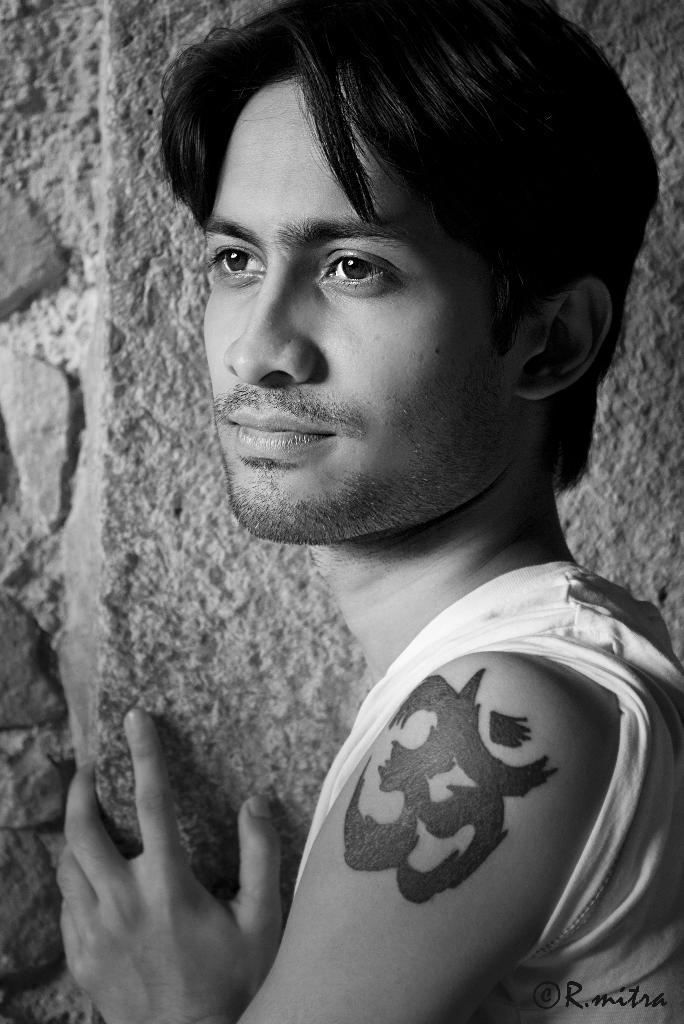What is present in the image? There is a man in the image. Can you describe any distinguishing features of the man? The man has a tattoo. What can be seen in the background of the image? There is a wall in the background of the image. What color is the man's nose in the image? The man's nose is not mentioned in the provided facts, so we cannot determine its color from the image. 